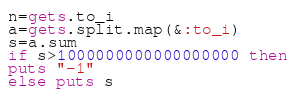Convert code to text. <code><loc_0><loc_0><loc_500><loc_500><_Ruby_>n=gets.to_i
a=gets.split.map(&:to_i)
s=a.sum
if s>1000000000000000000 then
puts "-1"
else puts s</code> 